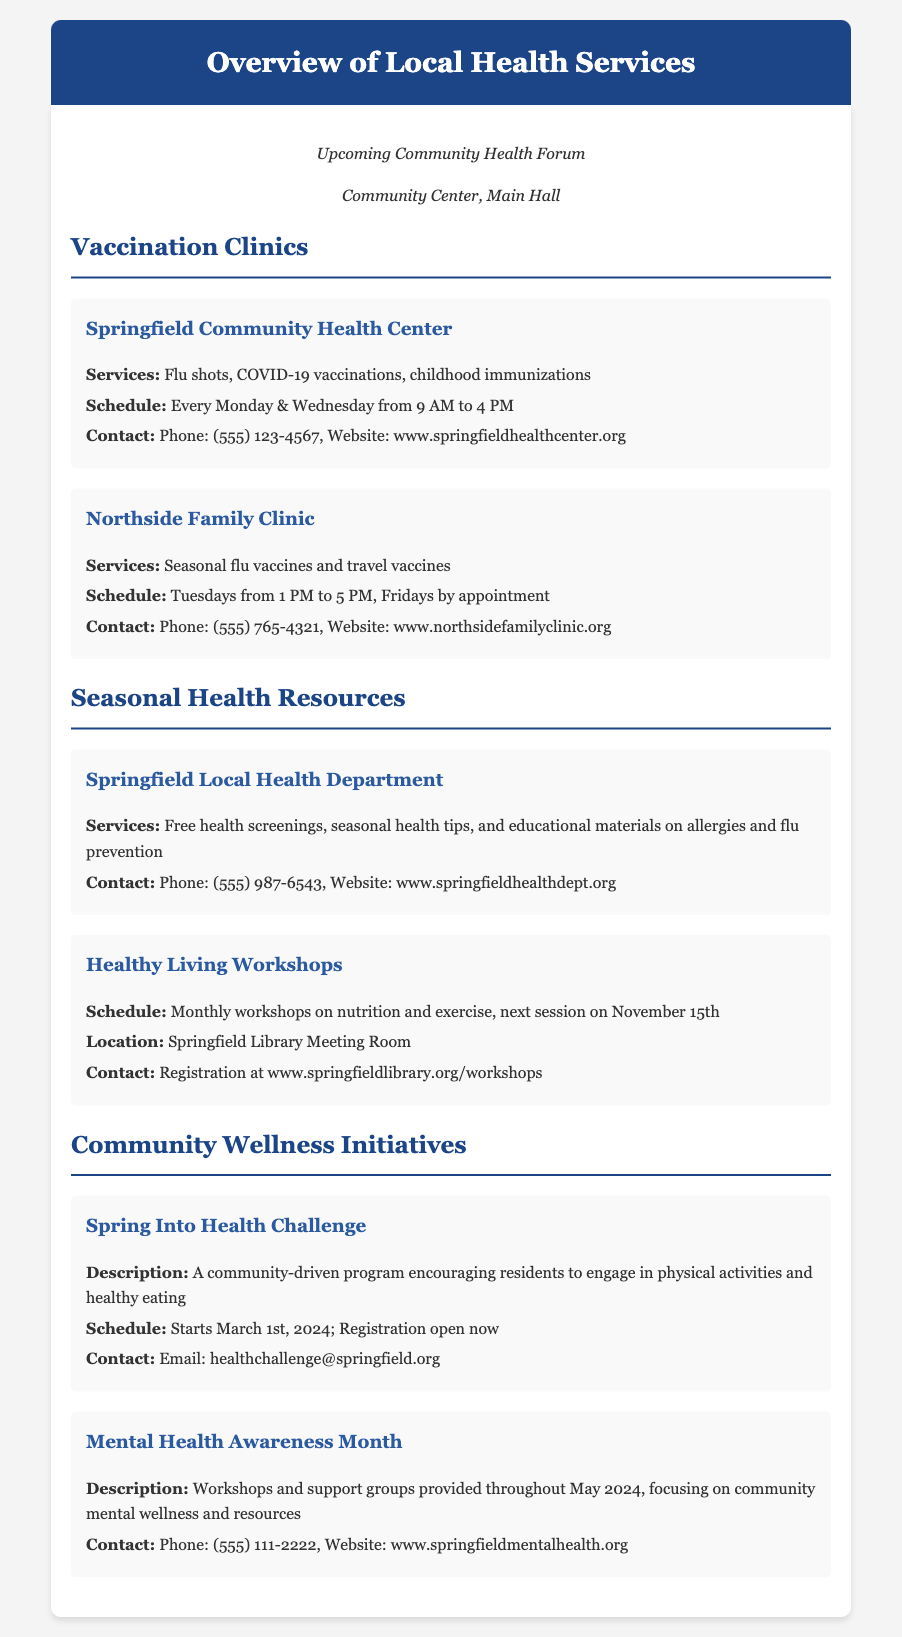What services are provided at the Springfield Community Health Center? The document mentions that the Springfield Community Health Center provides flu shots, COVID-19 vaccinations, and childhood immunizations.
Answer: Flu shots, COVID-19 vaccinations, childhood immunizations What is the schedule for vaccination clinics at Northside Family Clinic? According to the document, Northside Family Clinic has vaccination clinics on Tuesdays from 1 PM to 5 PM and Fridays by appointment.
Answer: Tuesdays 1 PM to 5 PM, Fridays by appointment When does the Spring Into Health Challenge start? The document states that the Spring Into Health Challenge starts on March 1st, 2024.
Answer: March 1st, 2024 What services does the Springfield Local Health Department offer? The Springfield Local Health Department offers free health screenings, seasonal health tips, and educational materials on allergies and flu prevention.
Answer: Free health screenings, seasonal health tips, educational materials Which location will host the next Healthy Living Workshop? The document indicates that the next Healthy Living Workshop will be held at the Springfield Library Meeting Room.
Answer: Springfield Library Meeting Room What is the contact method for the Spring Into Health Challenge? The document specifies that interested participants can contact via email for the Spring Into Health Challenge.
Answer: Email: healthchallenge@springfield.org How often do workshops occur according to the Healthy Living Workshops section? The document states that Healthy Living Workshops are monthly.
Answer: Monthly What is the focus of the Mental Health Awareness Month initiative? The document explains that Mental Health Awareness Month focuses on community mental wellness and resources.
Answer: Community mental wellness and resources 